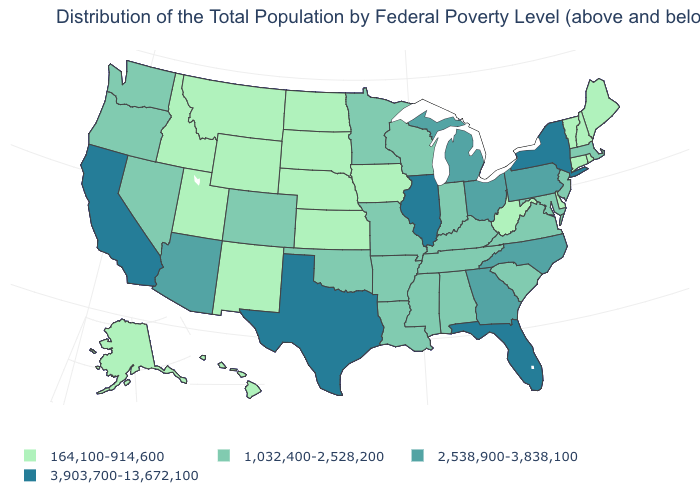Is the legend a continuous bar?
Answer briefly. No. What is the value of New Hampshire?
Answer briefly. 164,100-914,600. Does Arizona have a lower value than Kansas?
Concise answer only. No. What is the value of Minnesota?
Short answer required. 1,032,400-2,528,200. Name the states that have a value in the range 3,903,700-13,672,100?
Quick response, please. California, Florida, Illinois, New York, Texas. Which states hav the highest value in the Northeast?
Quick response, please. New York. What is the value of Hawaii?
Write a very short answer. 164,100-914,600. Does the map have missing data?
Keep it brief. No. Name the states that have a value in the range 2,538,900-3,838,100?
Write a very short answer. Arizona, Georgia, Michigan, North Carolina, Ohio, Pennsylvania. What is the lowest value in the USA?
Give a very brief answer. 164,100-914,600. Among the states that border New Mexico , does Utah have the lowest value?
Keep it brief. Yes. What is the value of Maine?
Quick response, please. 164,100-914,600. Does Vermont have the highest value in the Northeast?
Quick response, please. No. What is the highest value in the Northeast ?
Keep it brief. 3,903,700-13,672,100. Name the states that have a value in the range 2,538,900-3,838,100?
Give a very brief answer. Arizona, Georgia, Michigan, North Carolina, Ohio, Pennsylvania. 